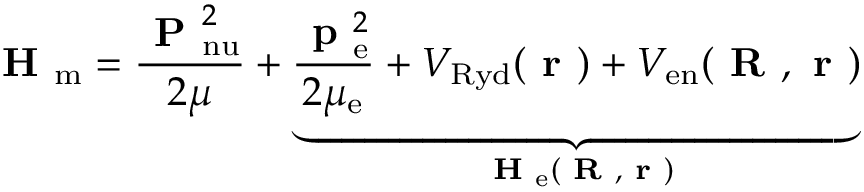<formula> <loc_0><loc_0><loc_500><loc_500>H _ { m } = \frac { P _ { n u } ^ { 2 } } { 2 \mu } + \underbrace { \frac { p _ { e } ^ { 2 } } { 2 \mu _ { e } } + V _ { R y d } ( r ) + V _ { e n } ( R , r ) } _ { H _ { e } ( R , r ) }</formula> 